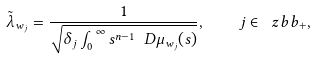<formula> <loc_0><loc_0><loc_500><loc_500>\tilde { \lambda } _ { w _ { j } } = \frac { 1 } { \sqrt { \delta _ { j } \int _ { 0 } ^ { \infty } s ^ { n - 1 } \ D \mu _ { w _ { j } } ( s ) } } , \quad j \in \ z b b _ { + } ,</formula> 